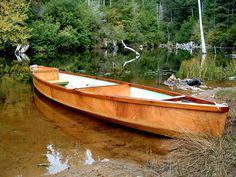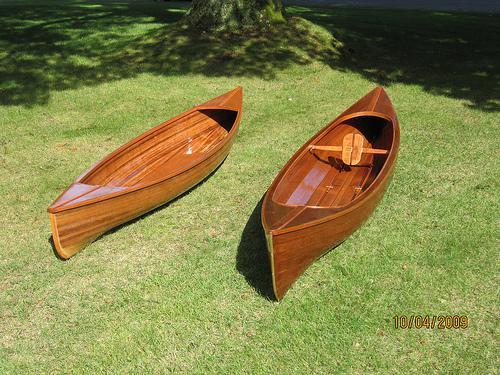The first image is the image on the left, the second image is the image on the right. For the images shown, is this caption "One image shows side-by-side woodgrain canoes on land, and the other image includes a green canoe." true? Answer yes or no. No. The first image is the image on the left, the second image is the image on the right. Analyze the images presented: Is the assertion "The left image contains two canoes laying next to each other in the grass." valid? Answer yes or no. No. 